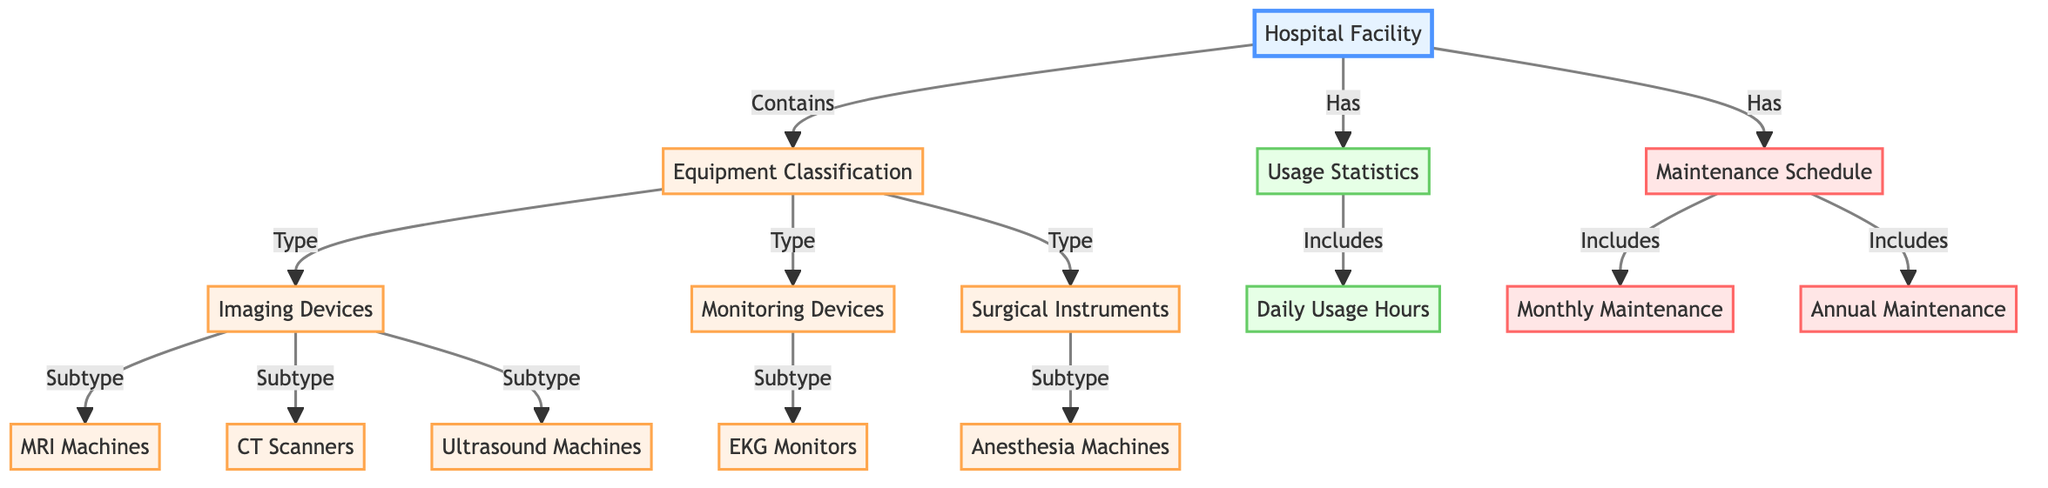What types of equipment are classified under imaging devices? In the diagram, imaging devices are classified into three subtypes: MRI machines, CT scanners, and ultrasound machines. By checking the connection from the "Imaging Devices" node, we can see the specific subtypes listed.
Answer: MRI machines, CT scanners, ultrasound machines How many types of equipment are classified in the diagram? The diagram has three main types of equipment: imaging devices, monitoring devices, and surgical instruments. This is determined by counting the distinct types directly linked to the "Equipment Classification" node.
Answer: 3 What is included in the usage statistics? The usage statistics include daily usage hours. This is indicated by the direct connection from the usage statistics node to the daily usage node.
Answer: Daily Usage Hours Which devices fall under monitoring devices? The monitoring devices include EKG monitors as the only subtype listed under the "Monitoring Devices" node, as seen through the direct connection.
Answer: EKG Monitors What maintenance schedule types are mentioned? The maintenance schedule types mentioned are monthly maintenance and annual maintenance. This can be understood by looking at the connections stemming from the maintenance schedule node.
Answer: Monthly Maintenance, Annual Maintenance How many imaging devices are specified in the diagram? There are three imaging devices specified: MRI machines, CT scanners, and ultrasound machines. This is derived from the enumeration of the subtypes connected to the imaging devices node.
Answer: 3 How does the hospital facility relate to equipment classification? The hospital facility contains the equipment classification, as indicated by the directed link from the hospital node to the equipment classification node in the diagram.
Answer: Contains What is the relationship between monitoring devices and the EKG monitor? The relationship is that EKG monitors are a subtype of monitoring devices, which is established by the direct connection in the diagram between the monitoring devices node and the EKG monitor node.
Answer: Subtype What type of data does the maintenance schedule provide? The maintenance schedule provides information about the types of maintenance: monthly and annual maintenance, which are directly connected to the maintenance schedule node.
Answer: Monthly and Annual Maintenance 